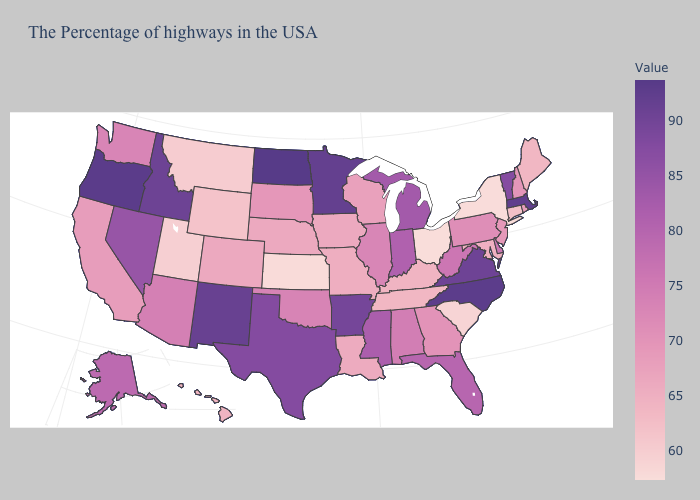Among the states that border Nevada , does Oregon have the highest value?
Give a very brief answer. Yes. Does Oklahoma have a higher value than New Mexico?
Answer briefly. No. Which states have the highest value in the USA?
Keep it brief. North Dakota. Which states hav the highest value in the MidWest?
Short answer required. North Dakota. Which states hav the highest value in the MidWest?
Write a very short answer. North Dakota. Does the map have missing data?
Keep it brief. No. 